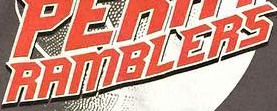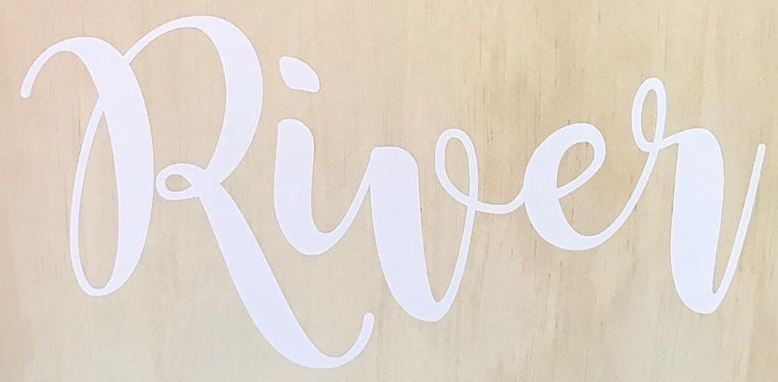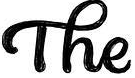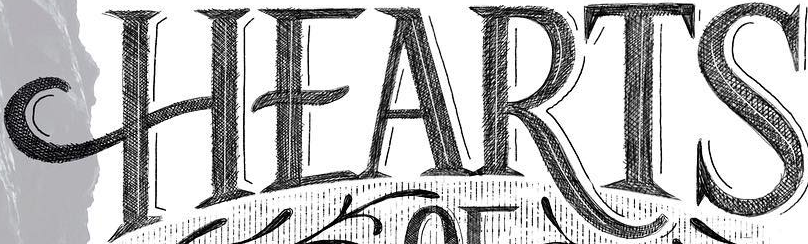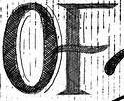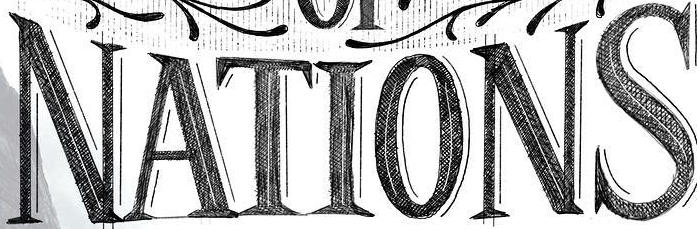What text appears in these images from left to right, separated by a semicolon? RAMBLERS; River; The; HEARTS; OF; NATIONS 